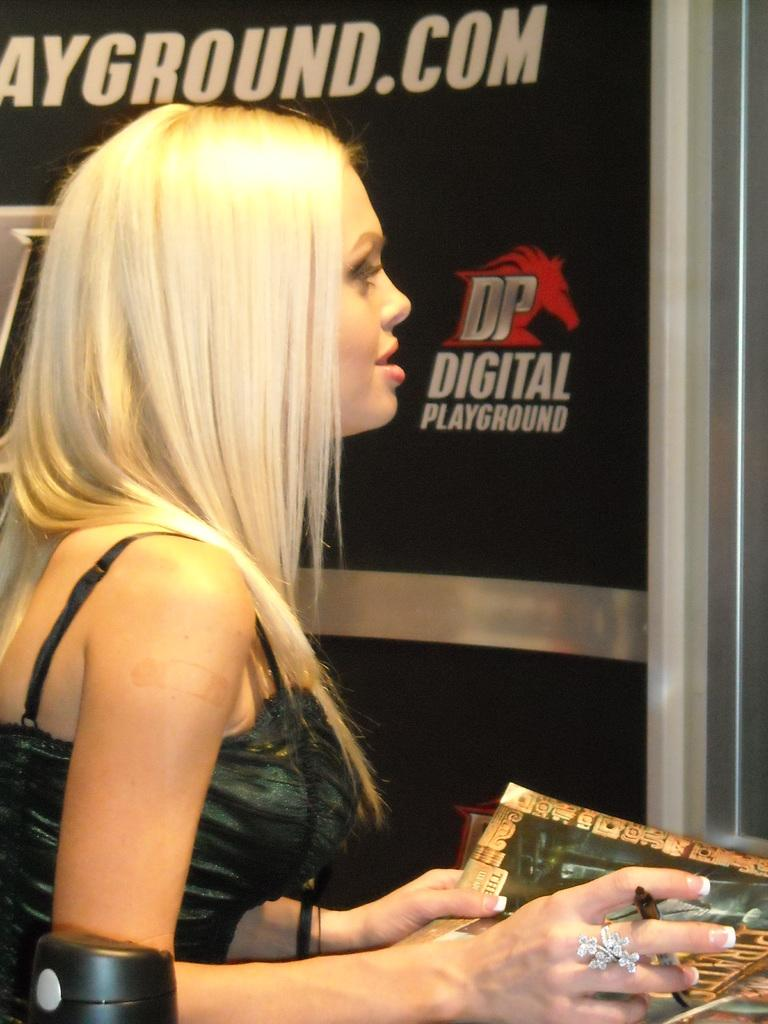What is the person in the image doing? The person in the image is holding a pen and paper. What can be seen in the background of the image? The background of the image is darker. What text is present in the image? The text "com" and "DP digital playground" are present in the image. Is there a playground in the image? Yes, there is a playground in the image. What type of square object is being used to carry items in the image? There is no square object being used to carry items in the image. What is inside the sack that the person is holding in the image? There is no sack or bag present in the image; the person is holding a pen and paper. 